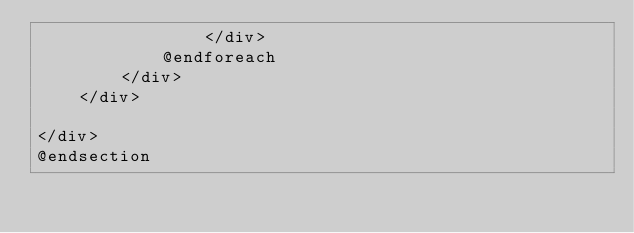<code> <loc_0><loc_0><loc_500><loc_500><_PHP_>                </div>
            @endforeach
        </div>
    </div>

</div>
@endsection
</code> 